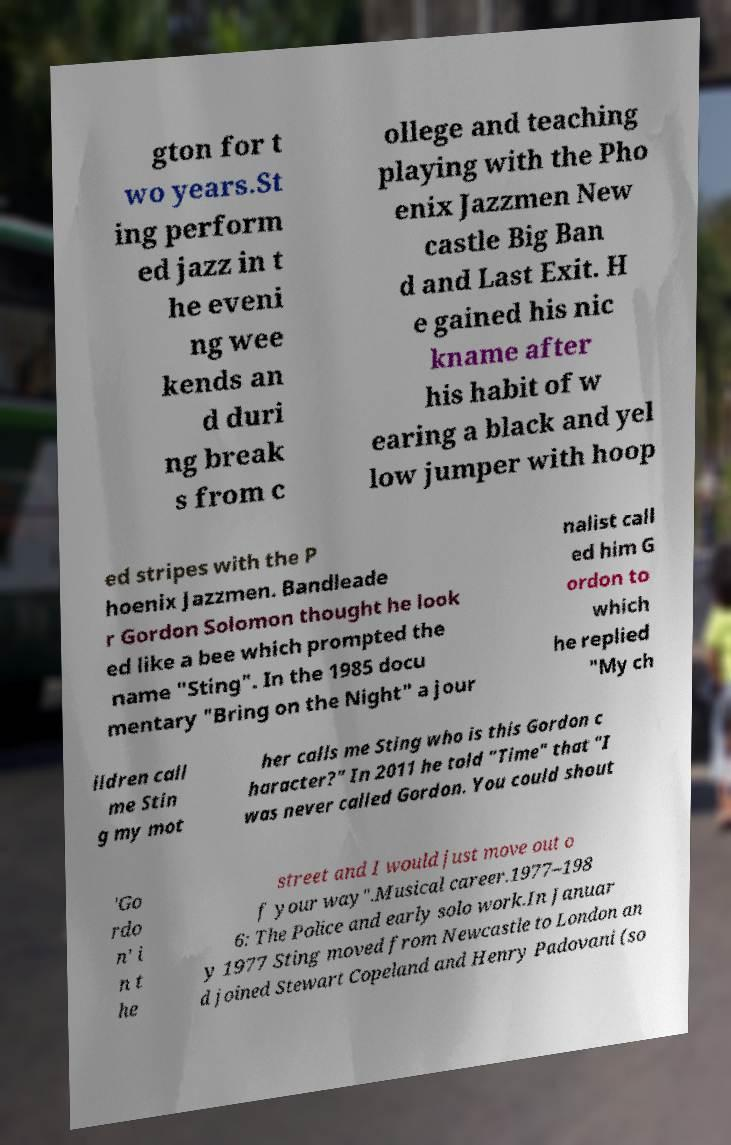There's text embedded in this image that I need extracted. Can you transcribe it verbatim? gton for t wo years.St ing perform ed jazz in t he eveni ng wee kends an d duri ng break s from c ollege and teaching playing with the Pho enix Jazzmen New castle Big Ban d and Last Exit. H e gained his nic kname after his habit of w earing a black and yel low jumper with hoop ed stripes with the P hoenix Jazzmen. Bandleade r Gordon Solomon thought he look ed like a bee which prompted the name "Sting". In the 1985 docu mentary "Bring on the Night" a jour nalist call ed him G ordon to which he replied "My ch ildren call me Stin g my mot her calls me Sting who is this Gordon c haracter?" In 2011 he told "Time" that "I was never called Gordon. You could shout 'Go rdo n' i n t he street and I would just move out o f your way".Musical career.1977–198 6: The Police and early solo work.In Januar y 1977 Sting moved from Newcastle to London an d joined Stewart Copeland and Henry Padovani (so 